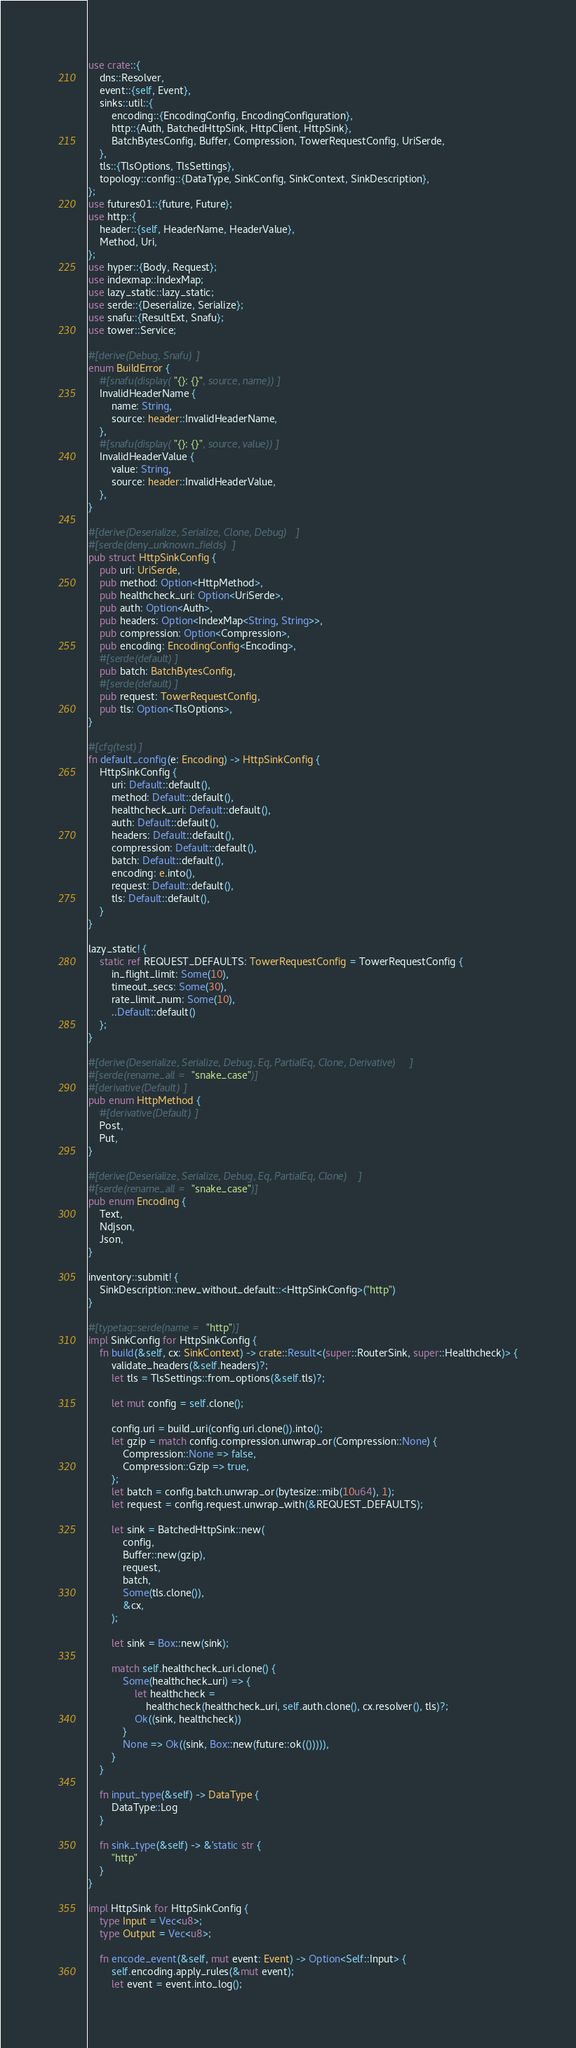<code> <loc_0><loc_0><loc_500><loc_500><_Rust_>use crate::{
    dns::Resolver,
    event::{self, Event},
    sinks::util::{
        encoding::{EncodingConfig, EncodingConfiguration},
        http::{Auth, BatchedHttpSink, HttpClient, HttpSink},
        BatchBytesConfig, Buffer, Compression, TowerRequestConfig, UriSerde,
    },
    tls::{TlsOptions, TlsSettings},
    topology::config::{DataType, SinkConfig, SinkContext, SinkDescription},
};
use futures01::{future, Future};
use http::{
    header::{self, HeaderName, HeaderValue},
    Method, Uri,
};
use hyper::{Body, Request};
use indexmap::IndexMap;
use lazy_static::lazy_static;
use serde::{Deserialize, Serialize};
use snafu::{ResultExt, Snafu};
use tower::Service;

#[derive(Debug, Snafu)]
enum BuildError {
    #[snafu(display("{}: {}", source, name))]
    InvalidHeaderName {
        name: String,
        source: header::InvalidHeaderName,
    },
    #[snafu(display("{}: {}", source, value))]
    InvalidHeaderValue {
        value: String,
        source: header::InvalidHeaderValue,
    },
}

#[derive(Deserialize, Serialize, Clone, Debug)]
#[serde(deny_unknown_fields)]
pub struct HttpSinkConfig {
    pub uri: UriSerde,
    pub method: Option<HttpMethod>,
    pub healthcheck_uri: Option<UriSerde>,
    pub auth: Option<Auth>,
    pub headers: Option<IndexMap<String, String>>,
    pub compression: Option<Compression>,
    pub encoding: EncodingConfig<Encoding>,
    #[serde(default)]
    pub batch: BatchBytesConfig,
    #[serde(default)]
    pub request: TowerRequestConfig,
    pub tls: Option<TlsOptions>,
}

#[cfg(test)]
fn default_config(e: Encoding) -> HttpSinkConfig {
    HttpSinkConfig {
        uri: Default::default(),
        method: Default::default(),
        healthcheck_uri: Default::default(),
        auth: Default::default(),
        headers: Default::default(),
        compression: Default::default(),
        batch: Default::default(),
        encoding: e.into(),
        request: Default::default(),
        tls: Default::default(),
    }
}

lazy_static! {
    static ref REQUEST_DEFAULTS: TowerRequestConfig = TowerRequestConfig {
        in_flight_limit: Some(10),
        timeout_secs: Some(30),
        rate_limit_num: Some(10),
        ..Default::default()
    };
}

#[derive(Deserialize, Serialize, Debug, Eq, PartialEq, Clone, Derivative)]
#[serde(rename_all = "snake_case")]
#[derivative(Default)]
pub enum HttpMethod {
    #[derivative(Default)]
    Post,
    Put,
}

#[derive(Deserialize, Serialize, Debug, Eq, PartialEq, Clone)]
#[serde(rename_all = "snake_case")]
pub enum Encoding {
    Text,
    Ndjson,
    Json,
}

inventory::submit! {
    SinkDescription::new_without_default::<HttpSinkConfig>("http")
}

#[typetag::serde(name = "http")]
impl SinkConfig for HttpSinkConfig {
    fn build(&self, cx: SinkContext) -> crate::Result<(super::RouterSink, super::Healthcheck)> {
        validate_headers(&self.headers)?;
        let tls = TlsSettings::from_options(&self.tls)?;

        let mut config = self.clone();

        config.uri = build_uri(config.uri.clone()).into();
        let gzip = match config.compression.unwrap_or(Compression::None) {
            Compression::None => false,
            Compression::Gzip => true,
        };
        let batch = config.batch.unwrap_or(bytesize::mib(10u64), 1);
        let request = config.request.unwrap_with(&REQUEST_DEFAULTS);

        let sink = BatchedHttpSink::new(
            config,
            Buffer::new(gzip),
            request,
            batch,
            Some(tls.clone()),
            &cx,
        );

        let sink = Box::new(sink);

        match self.healthcheck_uri.clone() {
            Some(healthcheck_uri) => {
                let healthcheck =
                    healthcheck(healthcheck_uri, self.auth.clone(), cx.resolver(), tls)?;
                Ok((sink, healthcheck))
            }
            None => Ok((sink, Box::new(future::ok(())))),
        }
    }

    fn input_type(&self) -> DataType {
        DataType::Log
    }

    fn sink_type(&self) -> &'static str {
        "http"
    }
}

impl HttpSink for HttpSinkConfig {
    type Input = Vec<u8>;
    type Output = Vec<u8>;

    fn encode_event(&self, mut event: Event) -> Option<Self::Input> {
        self.encoding.apply_rules(&mut event);
        let event = event.into_log();
</code> 